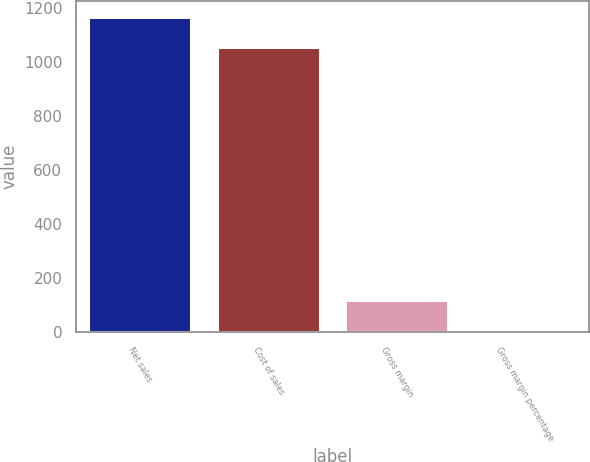Convert chart to OTSL. <chart><loc_0><loc_0><loc_500><loc_500><bar_chart><fcel>Net sales<fcel>Cost of sales<fcel>Gross margin<fcel>Gross margin percentage<nl><fcel>1167.7<fcel>1055<fcel>119.7<fcel>7<nl></chart> 